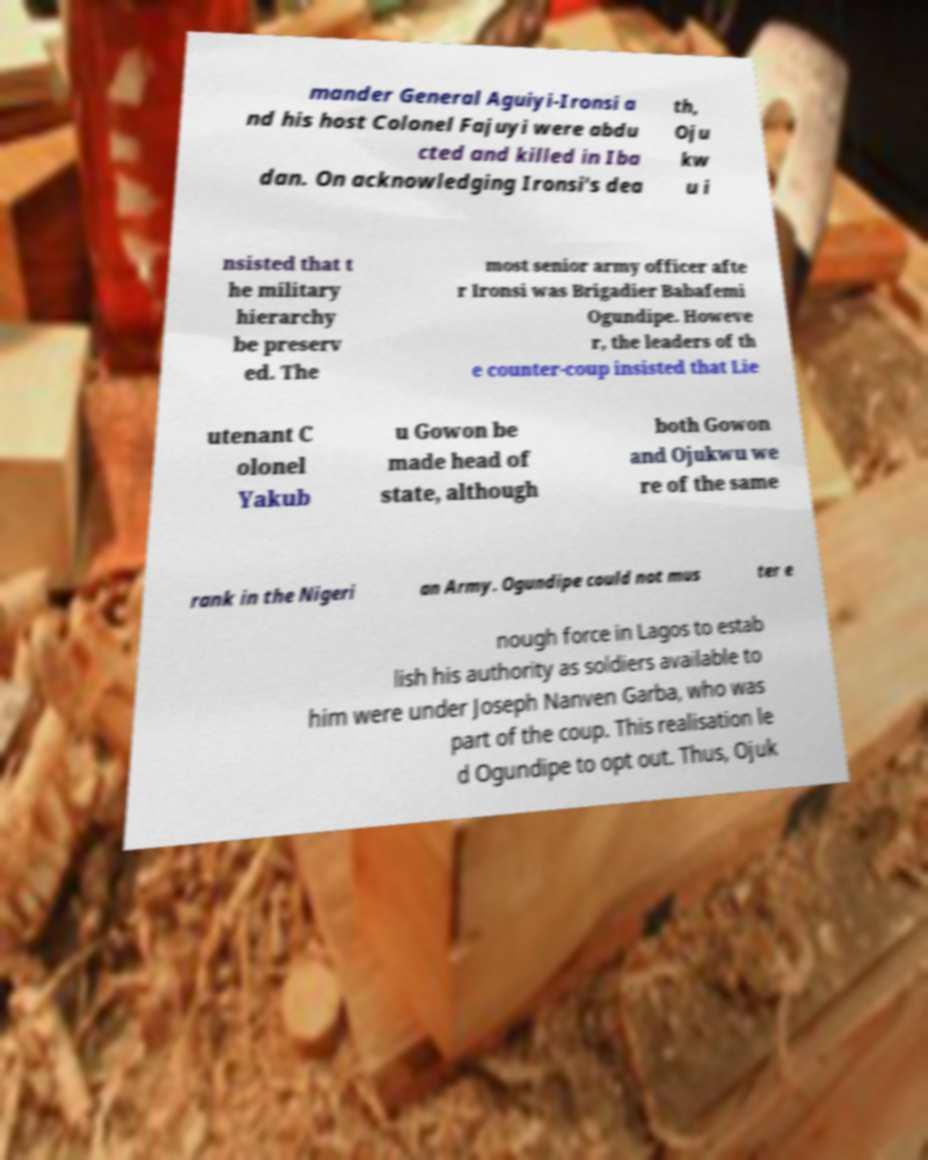What messages or text are displayed in this image? I need them in a readable, typed format. mander General Aguiyi-Ironsi a nd his host Colonel Fajuyi were abdu cted and killed in Iba dan. On acknowledging Ironsi's dea th, Oju kw u i nsisted that t he military hierarchy be preserv ed. The most senior army officer afte r Ironsi was Brigadier Babafemi Ogundipe. Howeve r, the leaders of th e counter-coup insisted that Lie utenant C olonel Yakub u Gowon be made head of state, although both Gowon and Ojukwu we re of the same rank in the Nigeri an Army. Ogundipe could not mus ter e nough force in Lagos to estab lish his authority as soldiers available to him were under Joseph Nanven Garba, who was part of the coup. This realisation le d Ogundipe to opt out. Thus, Ojuk 